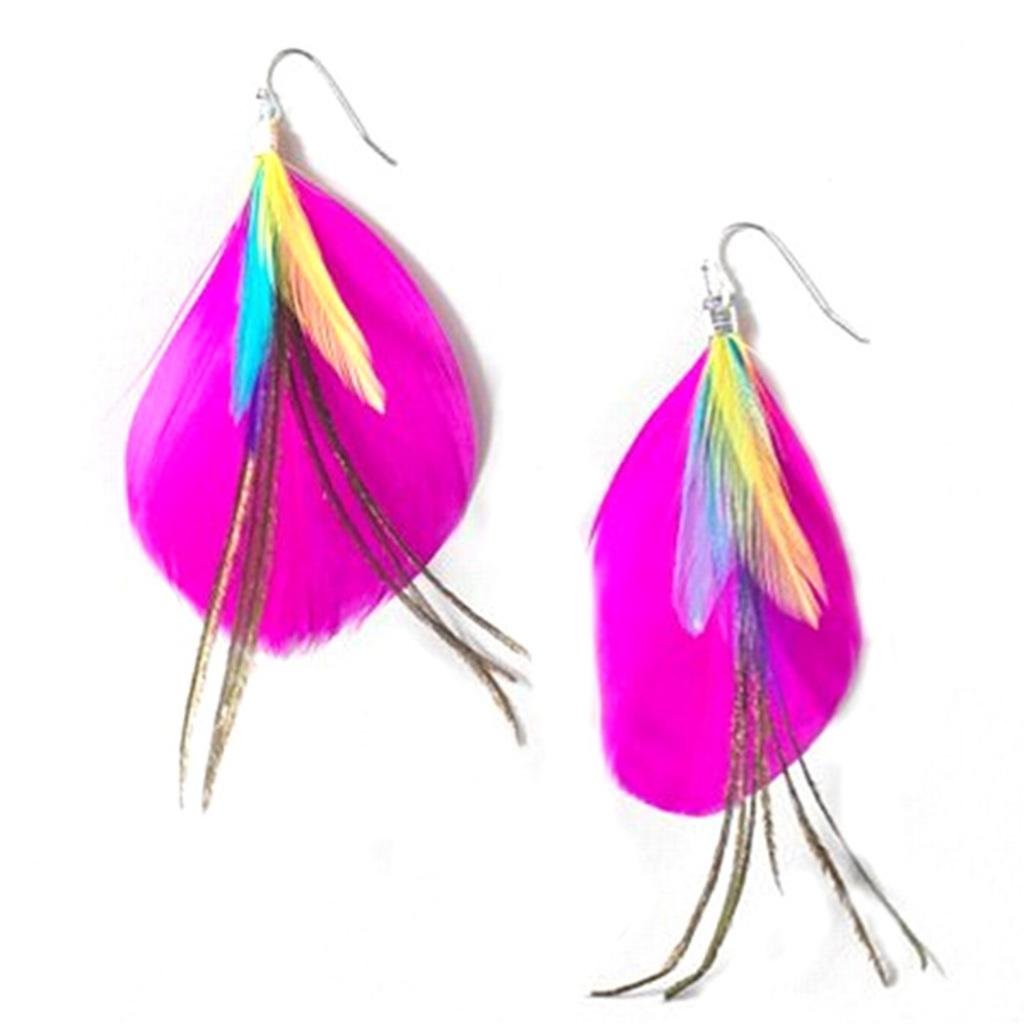What type of accessory is visible in the image? There are earrings in the image. What color is the background of the image? The background of the image is white. What type of fog can be seen in the image? There is no fog present in the image; it only features earrings and a white background. What hobbies are the people in the image engaged in? There are no people present in the image, so their hobbies cannot be determined. 